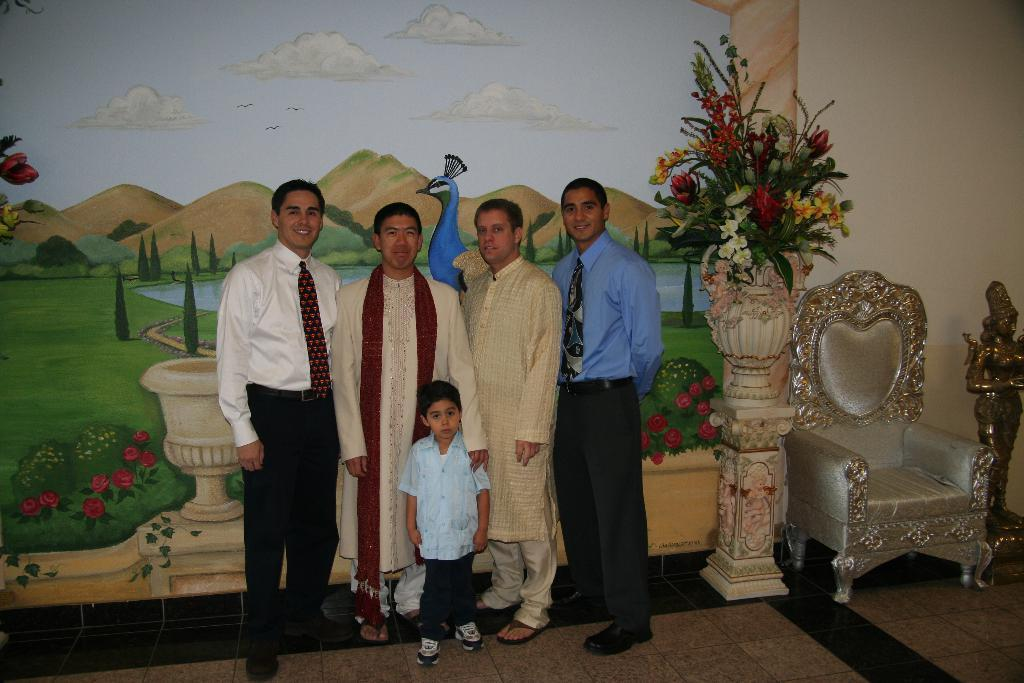What are the people in the image doing? The persons standing on the floor in the image are likely engaged in some activity or standing still. What type of furniture is present in the image? There is a chair in the image. What can be seen in the background of the image? There is a wall in the background of the image. What is on the wall in the image? There is a painting on the wall. What type of decorative item is present in the image? There is a flower vase in the image. How many toothbrushes are visible in the image? There are no toothbrushes present in the image. What is the wealth of the persons in the image? The provided facts do not give any information about the wealth of the persons in the image. 